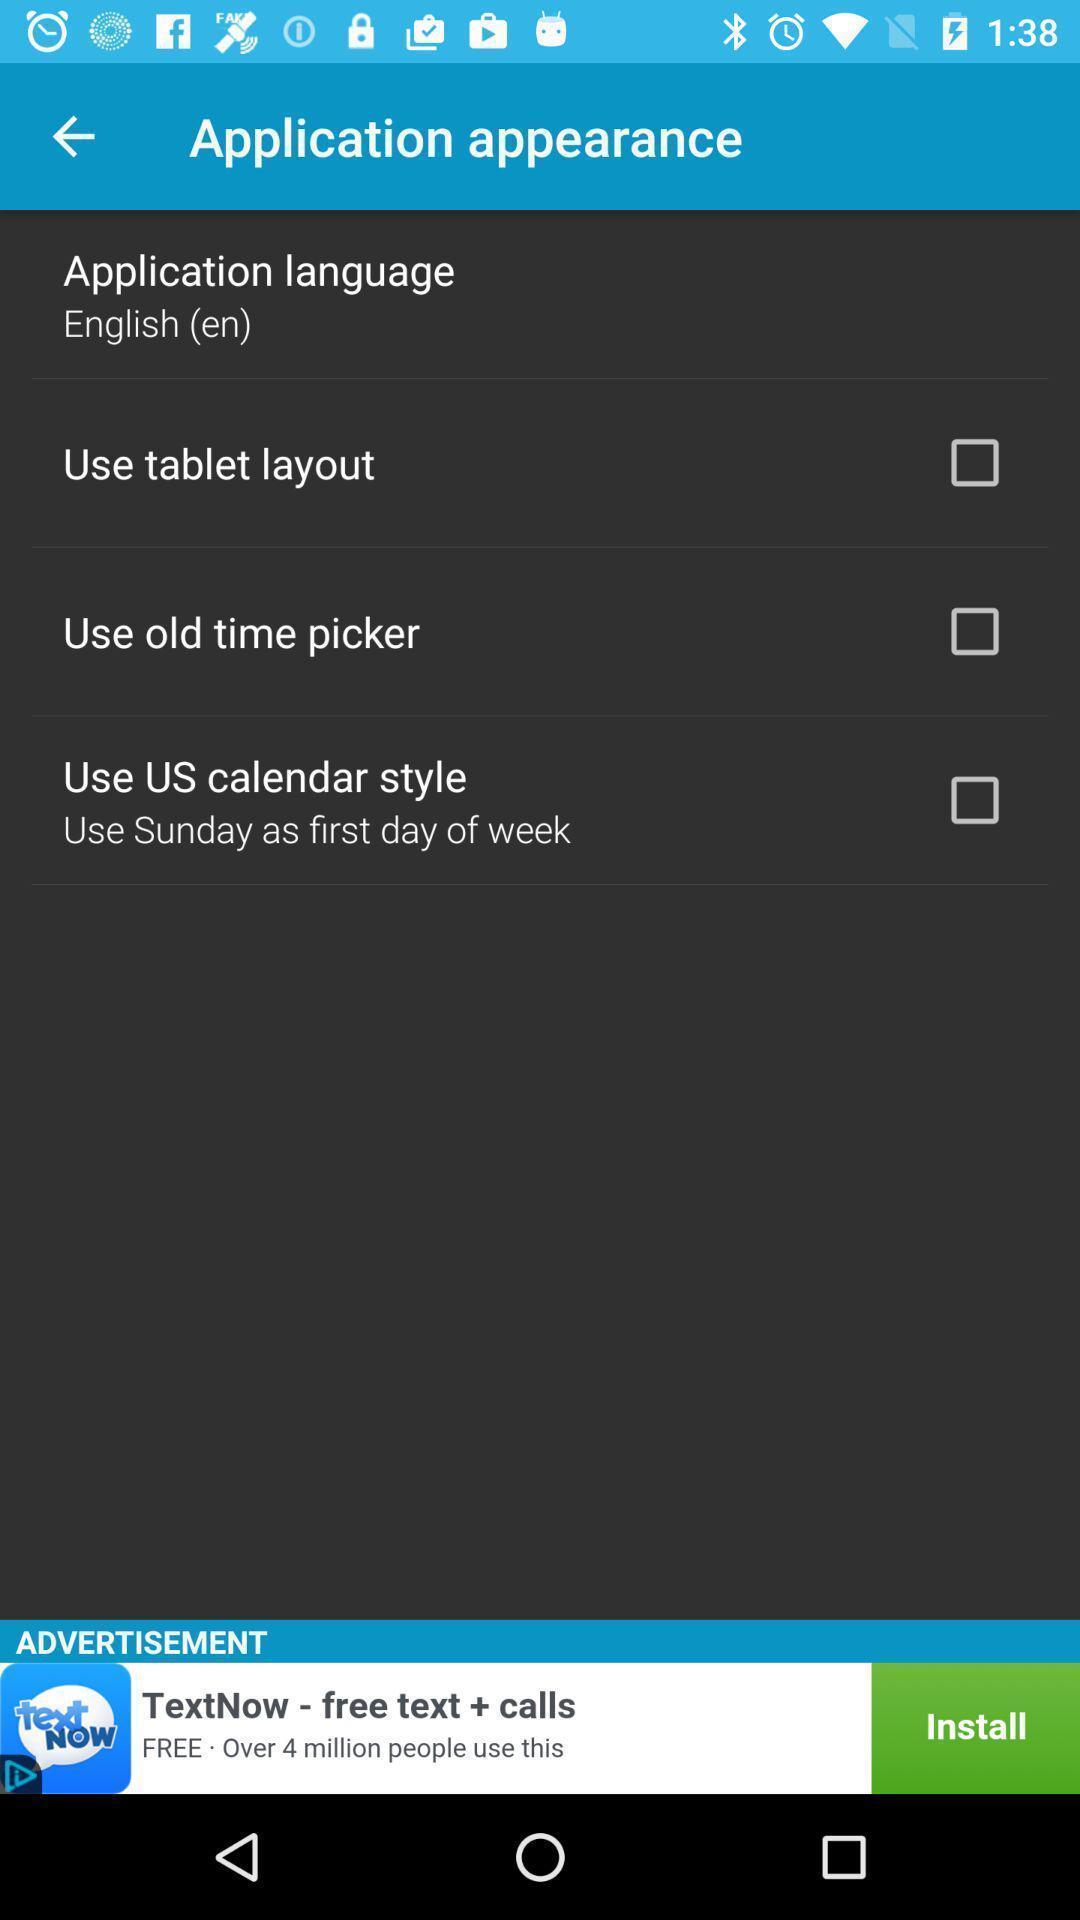Please provide a description for this image. Page appeared with display settings options. 